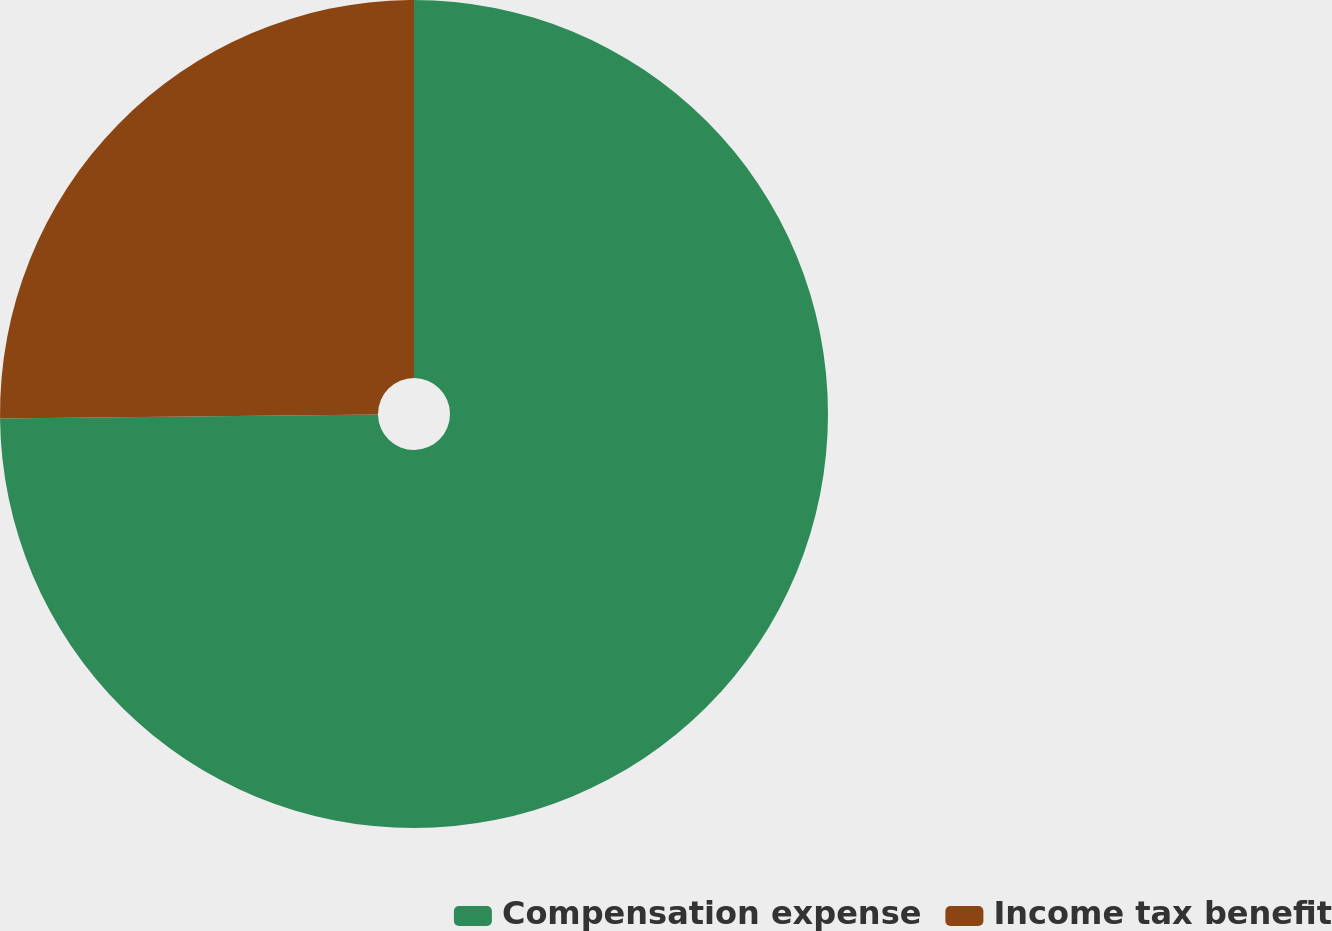Convert chart to OTSL. <chart><loc_0><loc_0><loc_500><loc_500><pie_chart><fcel>Compensation expense<fcel>Income tax benefit<nl><fcel>74.83%<fcel>25.17%<nl></chart> 